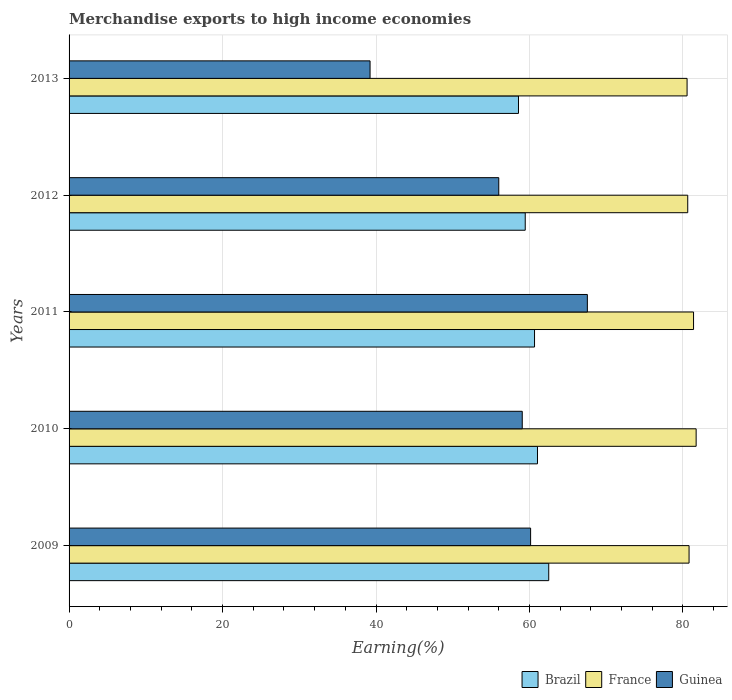How many different coloured bars are there?
Provide a short and direct response. 3. How many groups of bars are there?
Keep it short and to the point. 5. How many bars are there on the 4th tick from the top?
Keep it short and to the point. 3. How many bars are there on the 3rd tick from the bottom?
Ensure brevity in your answer.  3. What is the label of the 3rd group of bars from the top?
Your answer should be very brief. 2011. What is the percentage of amount earned from merchandise exports in Guinea in 2012?
Give a very brief answer. 56. Across all years, what is the maximum percentage of amount earned from merchandise exports in France?
Your response must be concise. 81.72. Across all years, what is the minimum percentage of amount earned from merchandise exports in Guinea?
Keep it short and to the point. 39.23. What is the total percentage of amount earned from merchandise exports in Brazil in the graph?
Give a very brief answer. 302.23. What is the difference between the percentage of amount earned from merchandise exports in Brazil in 2009 and that in 2011?
Make the answer very short. 1.85. What is the difference between the percentage of amount earned from merchandise exports in Guinea in 2009 and the percentage of amount earned from merchandise exports in France in 2012?
Make the answer very short. -20.48. What is the average percentage of amount earned from merchandise exports in France per year?
Offer a terse response. 81.01. In the year 2013, what is the difference between the percentage of amount earned from merchandise exports in Brazil and percentage of amount earned from merchandise exports in Guinea?
Keep it short and to the point. 19.34. In how many years, is the percentage of amount earned from merchandise exports in Brazil greater than 64 %?
Your answer should be very brief. 0. What is the ratio of the percentage of amount earned from merchandise exports in France in 2009 to that in 2010?
Provide a succinct answer. 0.99. Is the difference between the percentage of amount earned from merchandise exports in Brazil in 2009 and 2010 greater than the difference between the percentage of amount earned from merchandise exports in Guinea in 2009 and 2010?
Your answer should be compact. Yes. What is the difference between the highest and the second highest percentage of amount earned from merchandise exports in Guinea?
Offer a terse response. 7.4. What is the difference between the highest and the lowest percentage of amount earned from merchandise exports in Brazil?
Ensure brevity in your answer.  3.94. Is the sum of the percentage of amount earned from merchandise exports in Guinea in 2009 and 2010 greater than the maximum percentage of amount earned from merchandise exports in Brazil across all years?
Keep it short and to the point. Yes. What does the 1st bar from the top in 2012 represents?
Make the answer very short. Guinea. What does the 1st bar from the bottom in 2010 represents?
Your response must be concise. Brazil. Is it the case that in every year, the sum of the percentage of amount earned from merchandise exports in Guinea and percentage of amount earned from merchandise exports in Brazil is greater than the percentage of amount earned from merchandise exports in France?
Provide a short and direct response. Yes. How many years are there in the graph?
Ensure brevity in your answer.  5. What is the difference between two consecutive major ticks on the X-axis?
Provide a succinct answer. 20. Are the values on the major ticks of X-axis written in scientific E-notation?
Your answer should be compact. No. Does the graph contain grids?
Ensure brevity in your answer.  Yes. What is the title of the graph?
Make the answer very short. Merchandise exports to high income economies. What is the label or title of the X-axis?
Your answer should be very brief. Earning(%). What is the label or title of the Y-axis?
Make the answer very short. Years. What is the Earning(%) in Brazil in 2009?
Offer a very short reply. 62.51. What is the Earning(%) in France in 2009?
Make the answer very short. 80.8. What is the Earning(%) of Guinea in 2009?
Your response must be concise. 60.15. What is the Earning(%) of Brazil in 2010?
Ensure brevity in your answer.  61.05. What is the Earning(%) in France in 2010?
Give a very brief answer. 81.72. What is the Earning(%) in Guinea in 2010?
Your answer should be very brief. 59.06. What is the Earning(%) in Brazil in 2011?
Provide a short and direct response. 60.66. What is the Earning(%) in France in 2011?
Provide a succinct answer. 81.38. What is the Earning(%) in Guinea in 2011?
Make the answer very short. 67.55. What is the Earning(%) in Brazil in 2012?
Keep it short and to the point. 59.45. What is the Earning(%) in France in 2012?
Keep it short and to the point. 80.63. What is the Earning(%) of Guinea in 2012?
Your answer should be very brief. 56. What is the Earning(%) of Brazil in 2013?
Provide a succinct answer. 58.57. What is the Earning(%) in France in 2013?
Provide a short and direct response. 80.54. What is the Earning(%) of Guinea in 2013?
Your answer should be compact. 39.23. Across all years, what is the maximum Earning(%) of Brazil?
Offer a terse response. 62.51. Across all years, what is the maximum Earning(%) in France?
Make the answer very short. 81.72. Across all years, what is the maximum Earning(%) of Guinea?
Make the answer very short. 67.55. Across all years, what is the minimum Earning(%) in Brazil?
Offer a very short reply. 58.57. Across all years, what is the minimum Earning(%) in France?
Your answer should be compact. 80.54. Across all years, what is the minimum Earning(%) in Guinea?
Give a very brief answer. 39.23. What is the total Earning(%) in Brazil in the graph?
Make the answer very short. 302.23. What is the total Earning(%) in France in the graph?
Your answer should be very brief. 405.07. What is the total Earning(%) in Guinea in the graph?
Provide a short and direct response. 281.98. What is the difference between the Earning(%) of Brazil in 2009 and that in 2010?
Keep it short and to the point. 1.47. What is the difference between the Earning(%) in France in 2009 and that in 2010?
Make the answer very short. -0.92. What is the difference between the Earning(%) in Guinea in 2009 and that in 2010?
Ensure brevity in your answer.  1.09. What is the difference between the Earning(%) of Brazil in 2009 and that in 2011?
Provide a short and direct response. 1.85. What is the difference between the Earning(%) in France in 2009 and that in 2011?
Your response must be concise. -0.58. What is the difference between the Earning(%) of Guinea in 2009 and that in 2011?
Your answer should be very brief. -7.4. What is the difference between the Earning(%) of Brazil in 2009 and that in 2012?
Offer a terse response. 3.06. What is the difference between the Earning(%) in France in 2009 and that in 2012?
Your answer should be very brief. 0.17. What is the difference between the Earning(%) of Guinea in 2009 and that in 2012?
Offer a very short reply. 4.15. What is the difference between the Earning(%) of Brazil in 2009 and that in 2013?
Provide a succinct answer. 3.94. What is the difference between the Earning(%) of France in 2009 and that in 2013?
Ensure brevity in your answer.  0.26. What is the difference between the Earning(%) of Guinea in 2009 and that in 2013?
Ensure brevity in your answer.  20.92. What is the difference between the Earning(%) in Brazil in 2010 and that in 2011?
Provide a short and direct response. 0.39. What is the difference between the Earning(%) of France in 2010 and that in 2011?
Your answer should be very brief. 0.34. What is the difference between the Earning(%) in Guinea in 2010 and that in 2011?
Provide a short and direct response. -8.49. What is the difference between the Earning(%) of Brazil in 2010 and that in 2012?
Keep it short and to the point. 1.6. What is the difference between the Earning(%) of France in 2010 and that in 2012?
Make the answer very short. 1.1. What is the difference between the Earning(%) of Guinea in 2010 and that in 2012?
Keep it short and to the point. 3.06. What is the difference between the Earning(%) in Brazil in 2010 and that in 2013?
Offer a terse response. 2.48. What is the difference between the Earning(%) of France in 2010 and that in 2013?
Your answer should be very brief. 1.18. What is the difference between the Earning(%) of Guinea in 2010 and that in 2013?
Keep it short and to the point. 19.83. What is the difference between the Earning(%) of Brazil in 2011 and that in 2012?
Your answer should be compact. 1.21. What is the difference between the Earning(%) of France in 2011 and that in 2012?
Your answer should be very brief. 0.76. What is the difference between the Earning(%) of Guinea in 2011 and that in 2012?
Offer a very short reply. 11.55. What is the difference between the Earning(%) in Brazil in 2011 and that in 2013?
Offer a very short reply. 2.09. What is the difference between the Earning(%) of France in 2011 and that in 2013?
Provide a succinct answer. 0.84. What is the difference between the Earning(%) in Guinea in 2011 and that in 2013?
Keep it short and to the point. 28.32. What is the difference between the Earning(%) in Brazil in 2012 and that in 2013?
Your answer should be very brief. 0.88. What is the difference between the Earning(%) of France in 2012 and that in 2013?
Provide a short and direct response. 0.08. What is the difference between the Earning(%) in Guinea in 2012 and that in 2013?
Offer a terse response. 16.77. What is the difference between the Earning(%) of Brazil in 2009 and the Earning(%) of France in 2010?
Ensure brevity in your answer.  -19.21. What is the difference between the Earning(%) in Brazil in 2009 and the Earning(%) in Guinea in 2010?
Your response must be concise. 3.45. What is the difference between the Earning(%) in France in 2009 and the Earning(%) in Guinea in 2010?
Make the answer very short. 21.74. What is the difference between the Earning(%) of Brazil in 2009 and the Earning(%) of France in 2011?
Make the answer very short. -18.87. What is the difference between the Earning(%) of Brazil in 2009 and the Earning(%) of Guinea in 2011?
Make the answer very short. -5.03. What is the difference between the Earning(%) of France in 2009 and the Earning(%) of Guinea in 2011?
Give a very brief answer. 13.25. What is the difference between the Earning(%) in Brazil in 2009 and the Earning(%) in France in 2012?
Provide a succinct answer. -18.11. What is the difference between the Earning(%) of Brazil in 2009 and the Earning(%) of Guinea in 2012?
Provide a short and direct response. 6.51. What is the difference between the Earning(%) of France in 2009 and the Earning(%) of Guinea in 2012?
Your response must be concise. 24.8. What is the difference between the Earning(%) of Brazil in 2009 and the Earning(%) of France in 2013?
Your response must be concise. -18.03. What is the difference between the Earning(%) in Brazil in 2009 and the Earning(%) in Guinea in 2013?
Offer a terse response. 23.28. What is the difference between the Earning(%) of France in 2009 and the Earning(%) of Guinea in 2013?
Offer a terse response. 41.57. What is the difference between the Earning(%) of Brazil in 2010 and the Earning(%) of France in 2011?
Give a very brief answer. -20.34. What is the difference between the Earning(%) in Brazil in 2010 and the Earning(%) in Guinea in 2011?
Offer a terse response. -6.5. What is the difference between the Earning(%) of France in 2010 and the Earning(%) of Guinea in 2011?
Give a very brief answer. 14.18. What is the difference between the Earning(%) of Brazil in 2010 and the Earning(%) of France in 2012?
Offer a very short reply. -19.58. What is the difference between the Earning(%) of Brazil in 2010 and the Earning(%) of Guinea in 2012?
Provide a succinct answer. 5.05. What is the difference between the Earning(%) of France in 2010 and the Earning(%) of Guinea in 2012?
Your answer should be compact. 25.72. What is the difference between the Earning(%) of Brazil in 2010 and the Earning(%) of France in 2013?
Keep it short and to the point. -19.5. What is the difference between the Earning(%) of Brazil in 2010 and the Earning(%) of Guinea in 2013?
Your answer should be compact. 21.82. What is the difference between the Earning(%) of France in 2010 and the Earning(%) of Guinea in 2013?
Offer a terse response. 42.49. What is the difference between the Earning(%) of Brazil in 2011 and the Earning(%) of France in 2012?
Make the answer very short. -19.97. What is the difference between the Earning(%) in Brazil in 2011 and the Earning(%) in Guinea in 2012?
Your answer should be very brief. 4.66. What is the difference between the Earning(%) in France in 2011 and the Earning(%) in Guinea in 2012?
Make the answer very short. 25.38. What is the difference between the Earning(%) of Brazil in 2011 and the Earning(%) of France in 2013?
Offer a very short reply. -19.88. What is the difference between the Earning(%) in Brazil in 2011 and the Earning(%) in Guinea in 2013?
Keep it short and to the point. 21.43. What is the difference between the Earning(%) in France in 2011 and the Earning(%) in Guinea in 2013?
Make the answer very short. 42.16. What is the difference between the Earning(%) in Brazil in 2012 and the Earning(%) in France in 2013?
Your response must be concise. -21.09. What is the difference between the Earning(%) in Brazil in 2012 and the Earning(%) in Guinea in 2013?
Keep it short and to the point. 20.22. What is the difference between the Earning(%) in France in 2012 and the Earning(%) in Guinea in 2013?
Keep it short and to the point. 41.4. What is the average Earning(%) of Brazil per year?
Offer a very short reply. 60.45. What is the average Earning(%) of France per year?
Provide a short and direct response. 81.01. What is the average Earning(%) in Guinea per year?
Offer a terse response. 56.4. In the year 2009, what is the difference between the Earning(%) in Brazil and Earning(%) in France?
Give a very brief answer. -18.29. In the year 2009, what is the difference between the Earning(%) of Brazil and Earning(%) of Guinea?
Give a very brief answer. 2.36. In the year 2009, what is the difference between the Earning(%) in France and Earning(%) in Guinea?
Provide a succinct answer. 20.65. In the year 2010, what is the difference between the Earning(%) in Brazil and Earning(%) in France?
Your answer should be compact. -20.68. In the year 2010, what is the difference between the Earning(%) of Brazil and Earning(%) of Guinea?
Your response must be concise. 1.99. In the year 2010, what is the difference between the Earning(%) in France and Earning(%) in Guinea?
Ensure brevity in your answer.  22.66. In the year 2011, what is the difference between the Earning(%) in Brazil and Earning(%) in France?
Give a very brief answer. -20.72. In the year 2011, what is the difference between the Earning(%) in Brazil and Earning(%) in Guinea?
Offer a very short reply. -6.89. In the year 2011, what is the difference between the Earning(%) of France and Earning(%) of Guinea?
Offer a very short reply. 13.84. In the year 2012, what is the difference between the Earning(%) of Brazil and Earning(%) of France?
Provide a short and direct response. -21.18. In the year 2012, what is the difference between the Earning(%) in Brazil and Earning(%) in Guinea?
Your answer should be compact. 3.45. In the year 2012, what is the difference between the Earning(%) of France and Earning(%) of Guinea?
Your answer should be compact. 24.63. In the year 2013, what is the difference between the Earning(%) of Brazil and Earning(%) of France?
Your answer should be compact. -21.97. In the year 2013, what is the difference between the Earning(%) of Brazil and Earning(%) of Guinea?
Make the answer very short. 19.34. In the year 2013, what is the difference between the Earning(%) of France and Earning(%) of Guinea?
Your response must be concise. 41.31. What is the ratio of the Earning(%) of Brazil in 2009 to that in 2010?
Provide a succinct answer. 1.02. What is the ratio of the Earning(%) in France in 2009 to that in 2010?
Provide a succinct answer. 0.99. What is the ratio of the Earning(%) of Guinea in 2009 to that in 2010?
Give a very brief answer. 1.02. What is the ratio of the Earning(%) of Brazil in 2009 to that in 2011?
Give a very brief answer. 1.03. What is the ratio of the Earning(%) in Guinea in 2009 to that in 2011?
Provide a succinct answer. 0.89. What is the ratio of the Earning(%) in Brazil in 2009 to that in 2012?
Your answer should be very brief. 1.05. What is the ratio of the Earning(%) in France in 2009 to that in 2012?
Give a very brief answer. 1. What is the ratio of the Earning(%) in Guinea in 2009 to that in 2012?
Offer a very short reply. 1.07. What is the ratio of the Earning(%) in Brazil in 2009 to that in 2013?
Offer a very short reply. 1.07. What is the ratio of the Earning(%) of France in 2009 to that in 2013?
Offer a very short reply. 1. What is the ratio of the Earning(%) of Guinea in 2009 to that in 2013?
Your response must be concise. 1.53. What is the ratio of the Earning(%) in Brazil in 2010 to that in 2011?
Your response must be concise. 1.01. What is the ratio of the Earning(%) in France in 2010 to that in 2011?
Offer a terse response. 1. What is the ratio of the Earning(%) in Guinea in 2010 to that in 2011?
Offer a very short reply. 0.87. What is the ratio of the Earning(%) in Brazil in 2010 to that in 2012?
Make the answer very short. 1.03. What is the ratio of the Earning(%) of France in 2010 to that in 2012?
Your answer should be compact. 1.01. What is the ratio of the Earning(%) of Guinea in 2010 to that in 2012?
Your answer should be compact. 1.05. What is the ratio of the Earning(%) in Brazil in 2010 to that in 2013?
Offer a very short reply. 1.04. What is the ratio of the Earning(%) in France in 2010 to that in 2013?
Keep it short and to the point. 1.01. What is the ratio of the Earning(%) of Guinea in 2010 to that in 2013?
Offer a terse response. 1.51. What is the ratio of the Earning(%) of Brazil in 2011 to that in 2012?
Offer a terse response. 1.02. What is the ratio of the Earning(%) in France in 2011 to that in 2012?
Provide a short and direct response. 1.01. What is the ratio of the Earning(%) of Guinea in 2011 to that in 2012?
Your answer should be compact. 1.21. What is the ratio of the Earning(%) of Brazil in 2011 to that in 2013?
Your answer should be compact. 1.04. What is the ratio of the Earning(%) of France in 2011 to that in 2013?
Ensure brevity in your answer.  1.01. What is the ratio of the Earning(%) of Guinea in 2011 to that in 2013?
Ensure brevity in your answer.  1.72. What is the ratio of the Earning(%) of Brazil in 2012 to that in 2013?
Provide a short and direct response. 1.01. What is the ratio of the Earning(%) in France in 2012 to that in 2013?
Your answer should be very brief. 1. What is the ratio of the Earning(%) of Guinea in 2012 to that in 2013?
Offer a terse response. 1.43. What is the difference between the highest and the second highest Earning(%) in Brazil?
Keep it short and to the point. 1.47. What is the difference between the highest and the second highest Earning(%) in France?
Ensure brevity in your answer.  0.34. What is the difference between the highest and the second highest Earning(%) in Guinea?
Keep it short and to the point. 7.4. What is the difference between the highest and the lowest Earning(%) in Brazil?
Ensure brevity in your answer.  3.94. What is the difference between the highest and the lowest Earning(%) of France?
Offer a very short reply. 1.18. What is the difference between the highest and the lowest Earning(%) of Guinea?
Ensure brevity in your answer.  28.32. 